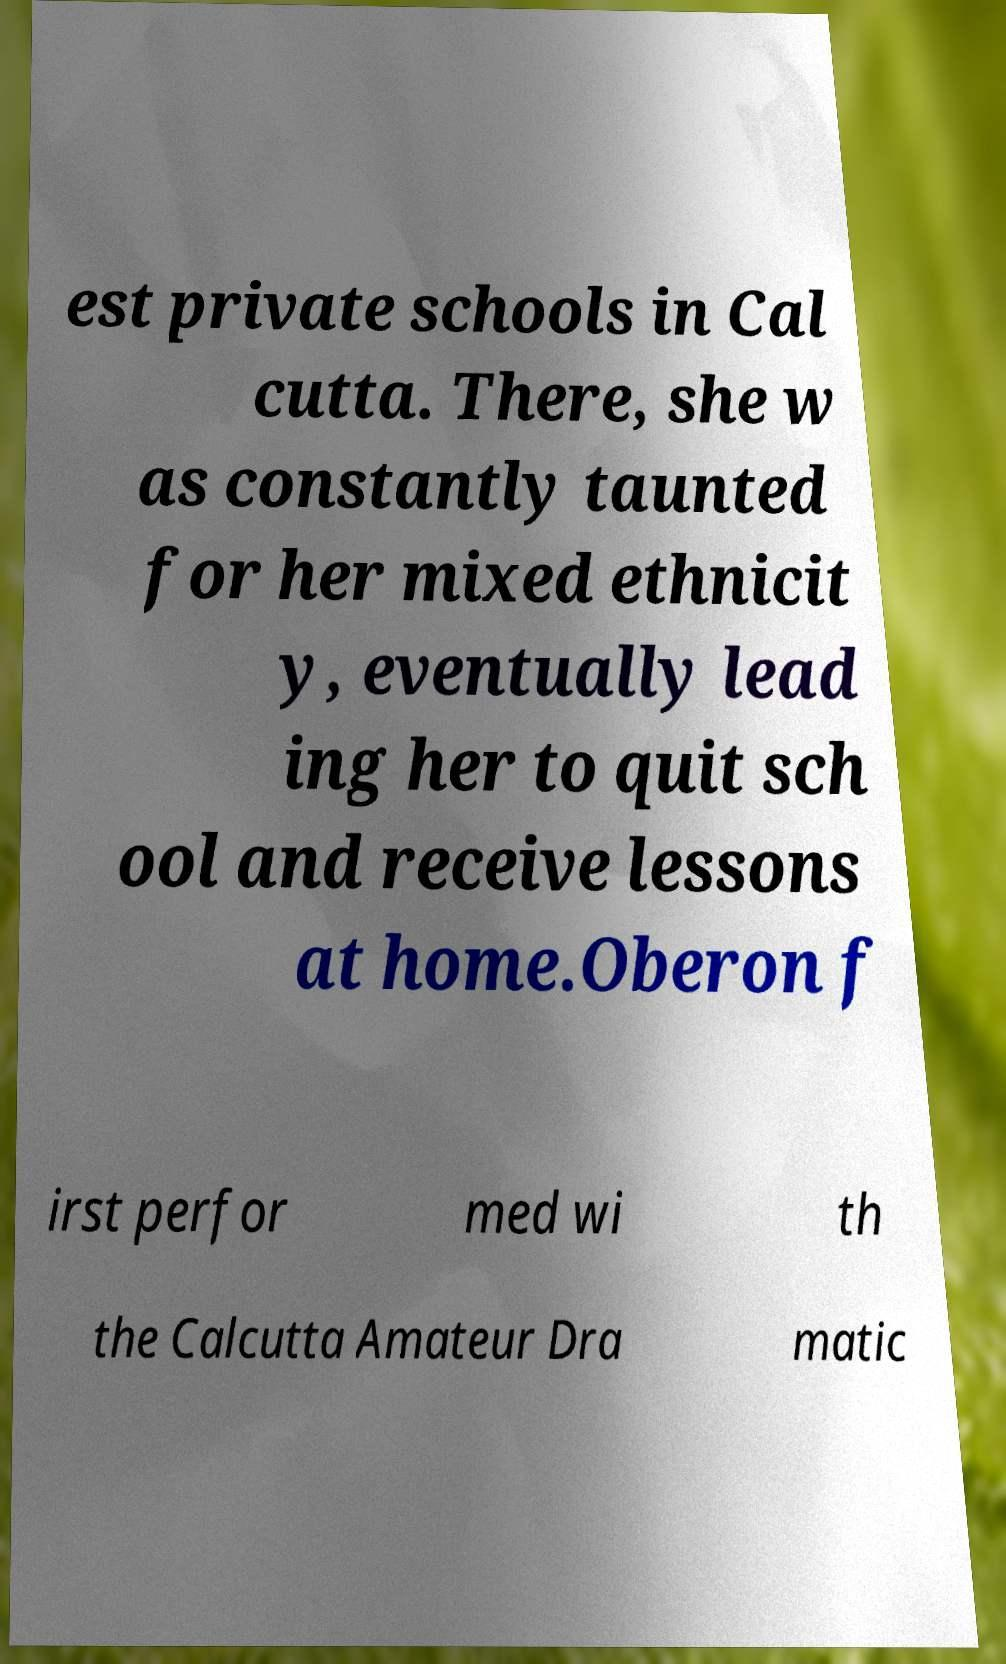Please read and relay the text visible in this image. What does it say? est private schools in Cal cutta. There, she w as constantly taunted for her mixed ethnicit y, eventually lead ing her to quit sch ool and receive lessons at home.Oberon f irst perfor med wi th the Calcutta Amateur Dra matic 